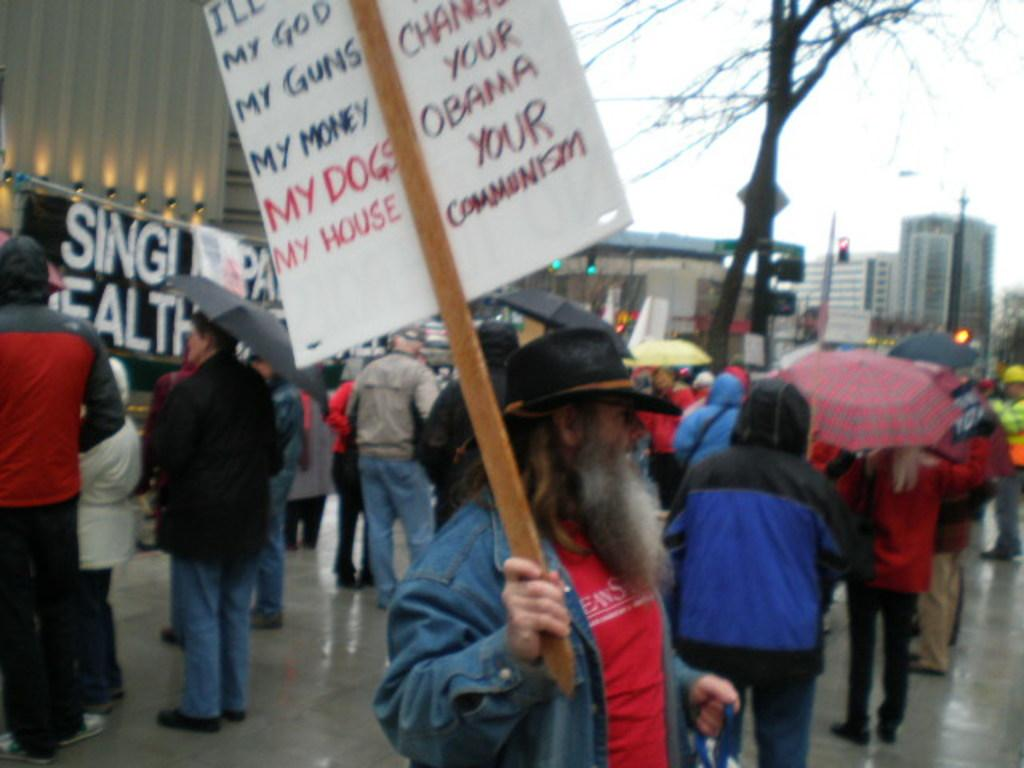What are the people in the image doing? The people in the image are standing and holding umbrellas. What is the man holding in the image? The man is holding a poster. What can be seen in the background of the image? There are buildings, trees, and the sky visible in the background of the image. What type of line is visible in the image? There is no line visible in the image. What is the range of the slope in the image? There is no slope present in the image. 